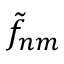Convert formula to latex. <formula><loc_0><loc_0><loc_500><loc_500>\tilde { f } _ { n m }</formula> 